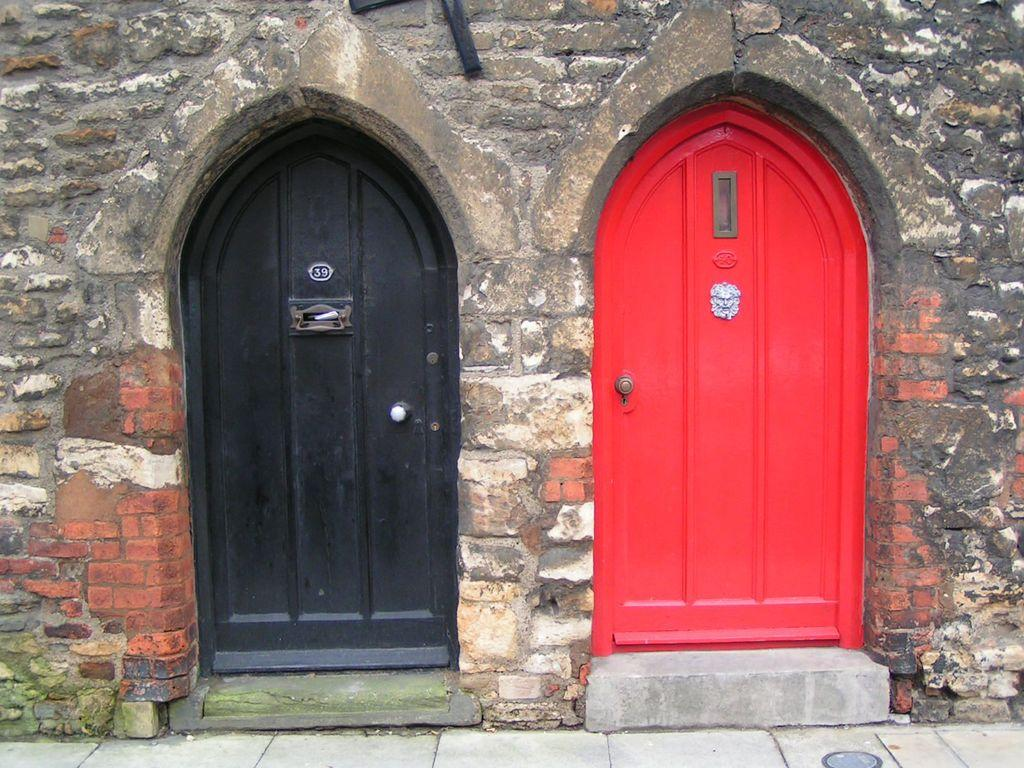What type of architectural feature can be seen in the image? There are doors and a wall visible in the image. What else can be seen in the image besides doors and a wall? There are other objects in the image. What is visible at the bottom of the image? The floor is visible at the bottom of the image. What type of button can be seen on the animal in the image? There is no animal or button present in the image. What color is the brick used to construct the wall in the image? The facts do not mention the color or material of the wall, so we cannot determine if it is made of brick or its color. 